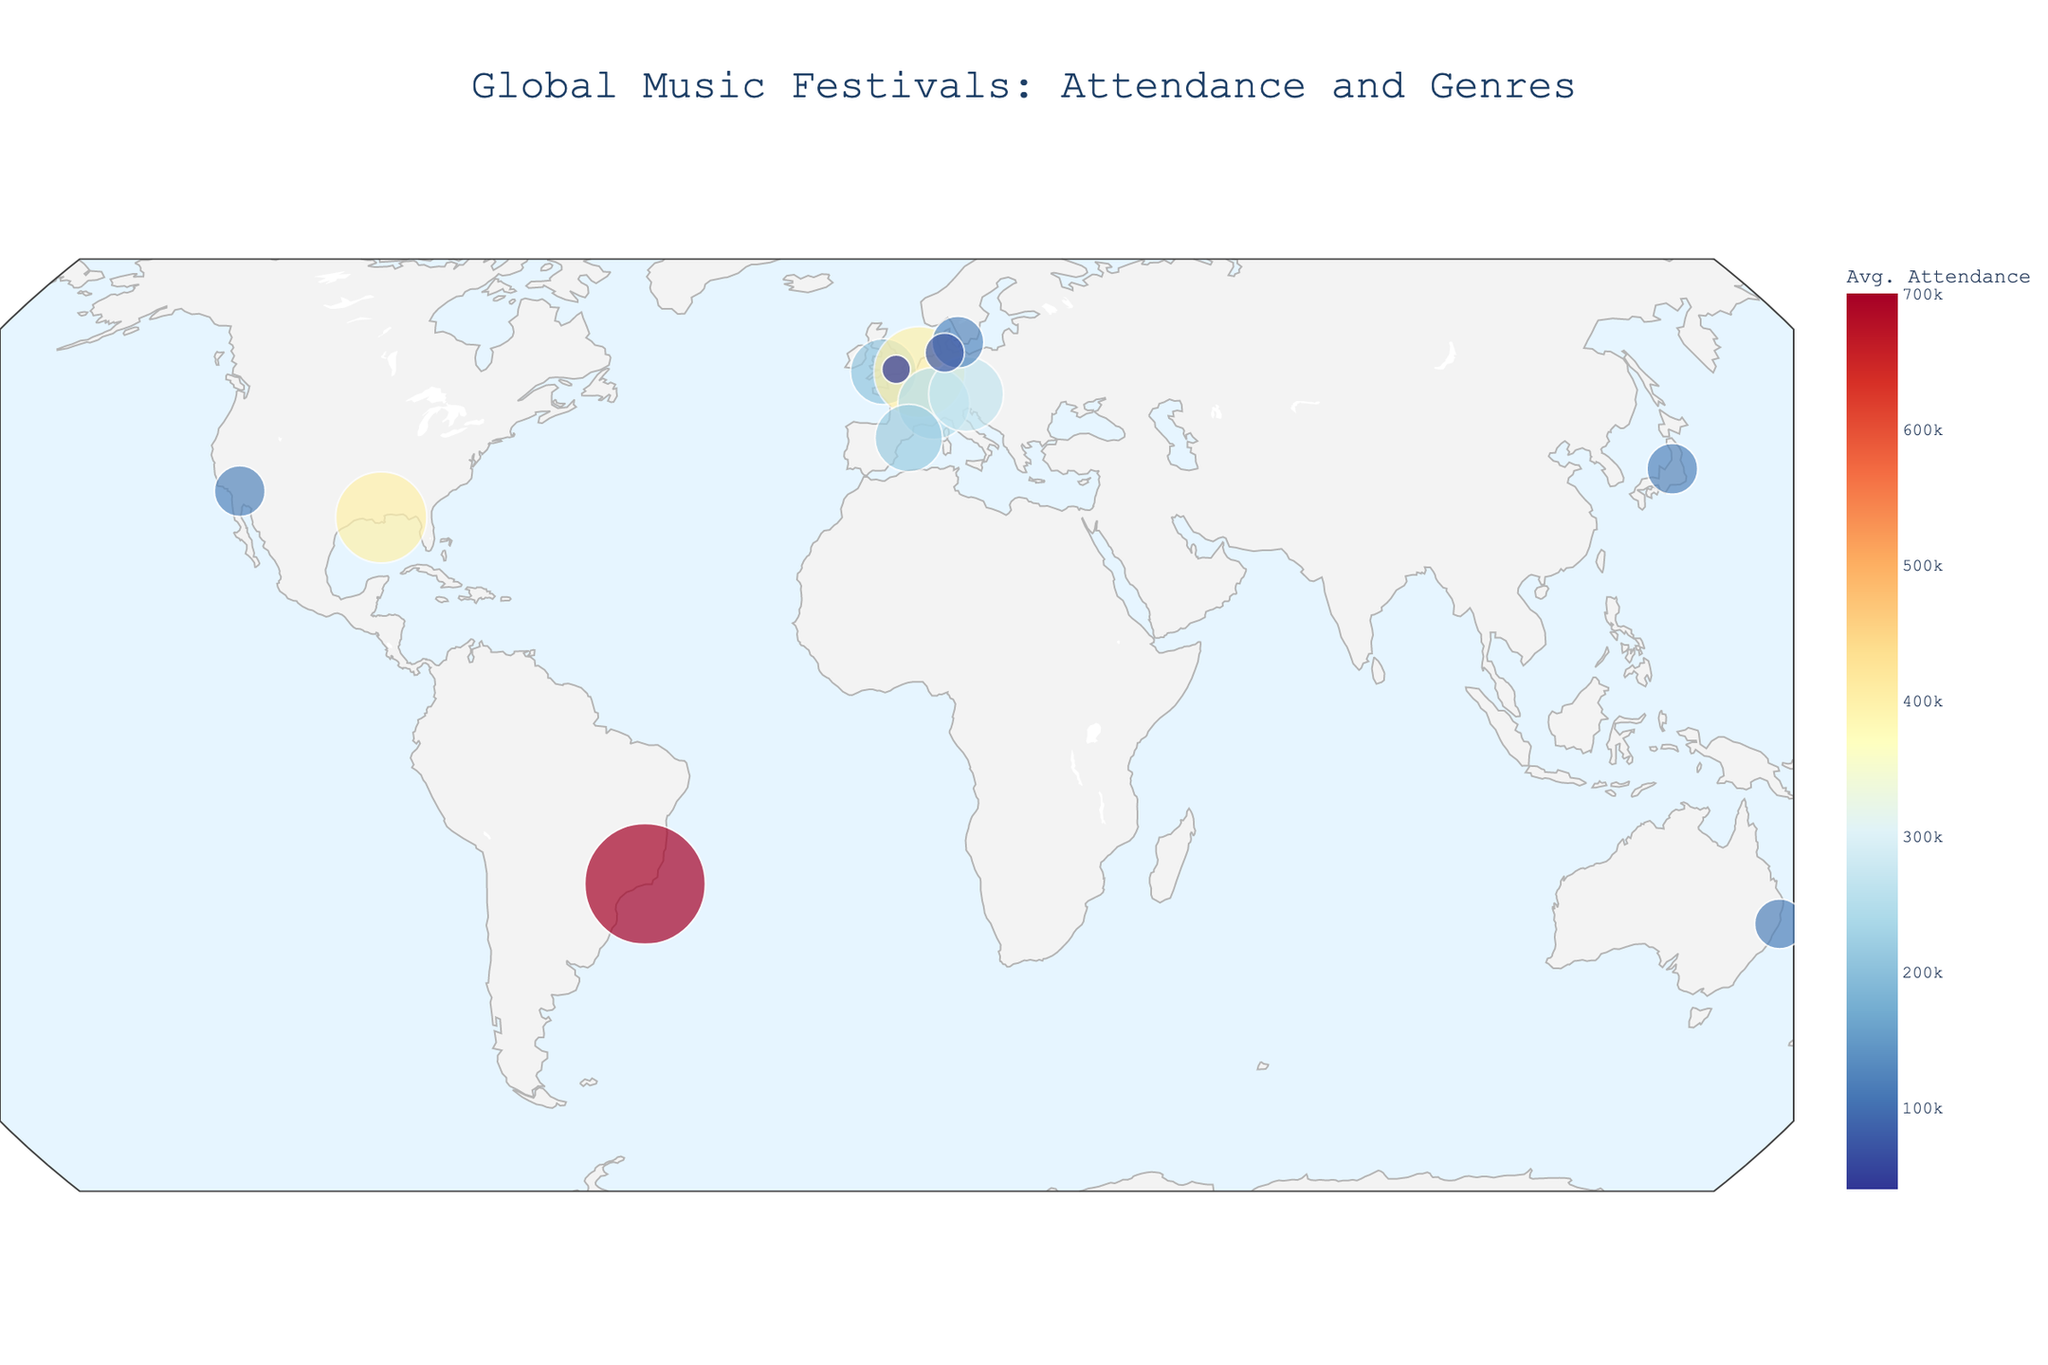Which festival has the highest average attendance? Looking at the color gradient, the festival in Rio de Janeiro, Brazil (Rock in Rio), stands out with the darkest color indicating the highest attendance.
Answer: Rock in Rio What's the average attendance of the two Jazz festivals? Identify the two Jazz festivals (Montreux Jazz Festival and New Orleans Jazz & Heritage Festival) from their labels. Add their average attendances (250,000 and 400,000) and divide by 2.
Answer: 325,000 Which genre is represented by the most festivals on the map? Count the number of festivals per genre by checking the labels associated with each dot. Rock appears the most frequently.
Answer: Rock What is the latitude of the festival with the lowest average attendance? Look for the smallest dot (WOMAD), check its location on the map, and find its latitude.
Answer: 51.5074 Compare the average attendances of Rock and Electronic festivals. Which one has a higher total attendance? Add up the average attendances of all Rock festivals (210,000 + 130,000 + 700,000 + 125,000 = 1,165,000) and compare with the total attendance for the Electronic festival (400,000). Rock has higher total attendance.
Answer: Rock Which continent hosts the most diverse range of genres? Examine the distribution and genre labels of festivals across continents. Europe has the most varied genres including Rock, Electronic, Jazz, Classical, Indie, and Metal.
Answer: Europe Is there a correlation between the festival's location and its average attendance? Observe the map to see if certain regions have consistently larger or smaller dots. No clear correlation by just visual inspection; attendance varies widely across all regions.
Answer: No clear correlation Which genres have their largest festivals in Europe? Check festivals labeled with their genre in Europe. Largest in Europe are Tomorrowland (Electronic) and Montreux Jazz Festival (Jazz).
Answer: Electronic, Jazz 